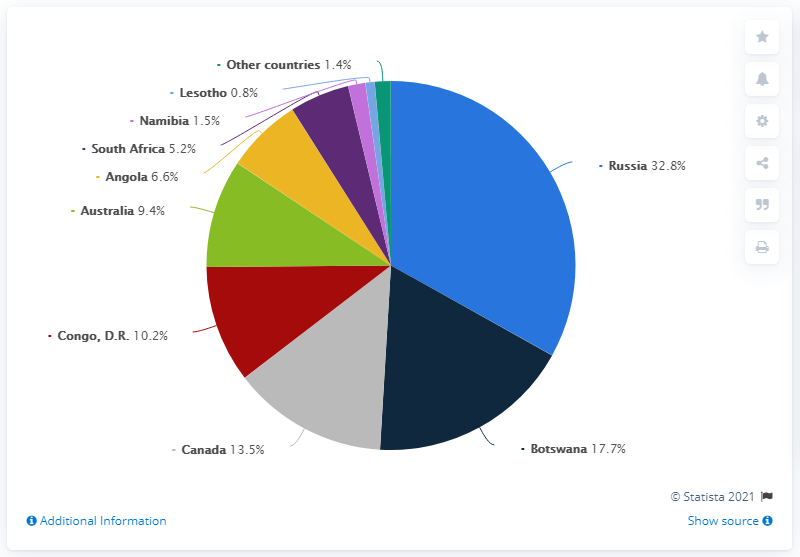Mention a couple of crucial points in this snapshot. The country with the highest value of rough diamond production distribution is Russia. In 2019, Russia was the world's largest producer of rough diamonds in terms of carats produced. In 2019, Russia produced 32.8% of the world's diamonds. According to the total diamond production value in 2019, Russia was the top country in the world. 